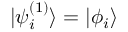<formula> <loc_0><loc_0><loc_500><loc_500>{ | \psi _ { i } ^ { ( 1 ) } \rangle = | \phi _ { i } \rangle }</formula> 